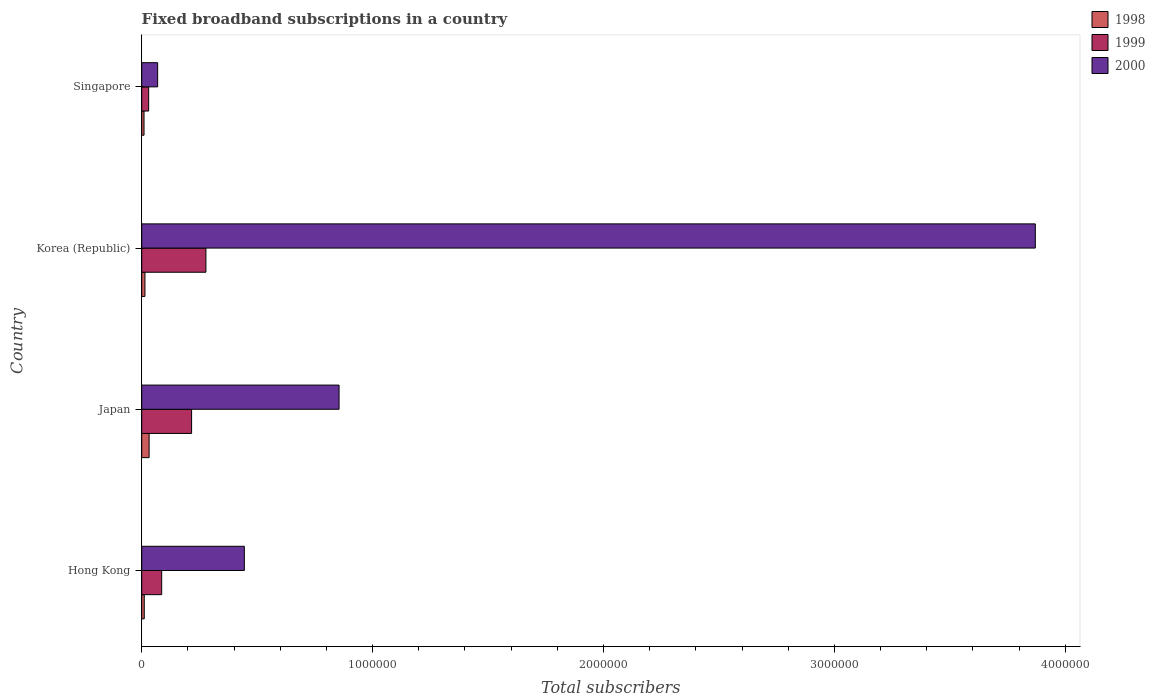How many groups of bars are there?
Keep it short and to the point. 4. Are the number of bars per tick equal to the number of legend labels?
Provide a short and direct response. Yes. Are the number of bars on each tick of the Y-axis equal?
Make the answer very short. Yes. How many bars are there on the 3rd tick from the top?
Provide a short and direct response. 3. What is the label of the 1st group of bars from the top?
Ensure brevity in your answer.  Singapore. Across all countries, what is the maximum number of broadband subscriptions in 1999?
Make the answer very short. 2.78e+05. Across all countries, what is the minimum number of broadband subscriptions in 1999?
Provide a short and direct response. 3.00e+04. In which country was the number of broadband subscriptions in 1999 minimum?
Make the answer very short. Singapore. What is the total number of broadband subscriptions in 1998 in the graph?
Provide a succinct answer. 6.70e+04. What is the difference between the number of broadband subscriptions in 1999 in Japan and that in Singapore?
Make the answer very short. 1.86e+05. What is the difference between the number of broadband subscriptions in 1999 in Singapore and the number of broadband subscriptions in 1998 in Korea (Republic)?
Make the answer very short. 1.60e+04. What is the average number of broadband subscriptions in 2000 per country?
Make the answer very short. 1.31e+06. What is the difference between the number of broadband subscriptions in 1998 and number of broadband subscriptions in 2000 in Japan?
Ensure brevity in your answer.  -8.23e+05. In how many countries, is the number of broadband subscriptions in 2000 greater than 600000 ?
Your answer should be very brief. 2. What is the ratio of the number of broadband subscriptions in 1999 in Korea (Republic) to that in Singapore?
Your answer should be very brief. 9.27. What is the difference between the highest and the second highest number of broadband subscriptions in 1999?
Ensure brevity in your answer.  6.20e+04. What is the difference between the highest and the lowest number of broadband subscriptions in 2000?
Your answer should be very brief. 3.80e+06. In how many countries, is the number of broadband subscriptions in 1999 greater than the average number of broadband subscriptions in 1999 taken over all countries?
Make the answer very short. 2. How many bars are there?
Provide a short and direct response. 12. Are all the bars in the graph horizontal?
Offer a very short reply. Yes. Are the values on the major ticks of X-axis written in scientific E-notation?
Your answer should be very brief. No. Does the graph contain any zero values?
Ensure brevity in your answer.  No. Does the graph contain grids?
Provide a short and direct response. No. How are the legend labels stacked?
Offer a very short reply. Vertical. What is the title of the graph?
Provide a short and direct response. Fixed broadband subscriptions in a country. Does "1979" appear as one of the legend labels in the graph?
Your answer should be compact. No. What is the label or title of the X-axis?
Give a very brief answer. Total subscribers. What is the label or title of the Y-axis?
Offer a terse response. Country. What is the Total subscribers of 1998 in Hong Kong?
Keep it short and to the point. 1.10e+04. What is the Total subscribers in 1999 in Hong Kong?
Your answer should be very brief. 8.65e+04. What is the Total subscribers in 2000 in Hong Kong?
Make the answer very short. 4.44e+05. What is the Total subscribers in 1998 in Japan?
Your answer should be very brief. 3.20e+04. What is the Total subscribers in 1999 in Japan?
Ensure brevity in your answer.  2.16e+05. What is the Total subscribers in 2000 in Japan?
Ensure brevity in your answer.  8.55e+05. What is the Total subscribers in 1998 in Korea (Republic)?
Your answer should be very brief. 1.40e+04. What is the Total subscribers in 1999 in Korea (Republic)?
Give a very brief answer. 2.78e+05. What is the Total subscribers in 2000 in Korea (Republic)?
Your response must be concise. 3.87e+06. What is the Total subscribers of 1998 in Singapore?
Provide a succinct answer. 10000. What is the Total subscribers in 1999 in Singapore?
Your answer should be very brief. 3.00e+04. What is the Total subscribers of 2000 in Singapore?
Keep it short and to the point. 6.90e+04. Across all countries, what is the maximum Total subscribers in 1998?
Make the answer very short. 3.20e+04. Across all countries, what is the maximum Total subscribers of 1999?
Your answer should be compact. 2.78e+05. Across all countries, what is the maximum Total subscribers of 2000?
Your answer should be compact. 3.87e+06. Across all countries, what is the minimum Total subscribers in 2000?
Provide a succinct answer. 6.90e+04. What is the total Total subscribers of 1998 in the graph?
Keep it short and to the point. 6.70e+04. What is the total Total subscribers of 1999 in the graph?
Make the answer very short. 6.10e+05. What is the total Total subscribers in 2000 in the graph?
Your response must be concise. 5.24e+06. What is the difference between the Total subscribers of 1998 in Hong Kong and that in Japan?
Offer a very short reply. -2.10e+04. What is the difference between the Total subscribers of 1999 in Hong Kong and that in Japan?
Your answer should be compact. -1.30e+05. What is the difference between the Total subscribers of 2000 in Hong Kong and that in Japan?
Your response must be concise. -4.10e+05. What is the difference between the Total subscribers of 1998 in Hong Kong and that in Korea (Republic)?
Provide a succinct answer. -3000. What is the difference between the Total subscribers in 1999 in Hong Kong and that in Korea (Republic)?
Provide a succinct answer. -1.92e+05. What is the difference between the Total subscribers in 2000 in Hong Kong and that in Korea (Republic)?
Offer a terse response. -3.43e+06. What is the difference between the Total subscribers of 1999 in Hong Kong and that in Singapore?
Offer a terse response. 5.65e+04. What is the difference between the Total subscribers of 2000 in Hong Kong and that in Singapore?
Your response must be concise. 3.75e+05. What is the difference between the Total subscribers in 1998 in Japan and that in Korea (Republic)?
Keep it short and to the point. 1.80e+04. What is the difference between the Total subscribers in 1999 in Japan and that in Korea (Republic)?
Keep it short and to the point. -6.20e+04. What is the difference between the Total subscribers of 2000 in Japan and that in Korea (Republic)?
Provide a short and direct response. -3.02e+06. What is the difference between the Total subscribers in 1998 in Japan and that in Singapore?
Your answer should be very brief. 2.20e+04. What is the difference between the Total subscribers in 1999 in Japan and that in Singapore?
Your answer should be very brief. 1.86e+05. What is the difference between the Total subscribers of 2000 in Japan and that in Singapore?
Your response must be concise. 7.86e+05. What is the difference between the Total subscribers in 1998 in Korea (Republic) and that in Singapore?
Offer a terse response. 4000. What is the difference between the Total subscribers of 1999 in Korea (Republic) and that in Singapore?
Provide a succinct answer. 2.48e+05. What is the difference between the Total subscribers in 2000 in Korea (Republic) and that in Singapore?
Provide a succinct answer. 3.80e+06. What is the difference between the Total subscribers in 1998 in Hong Kong and the Total subscribers in 1999 in Japan?
Ensure brevity in your answer.  -2.05e+05. What is the difference between the Total subscribers in 1998 in Hong Kong and the Total subscribers in 2000 in Japan?
Your response must be concise. -8.44e+05. What is the difference between the Total subscribers of 1999 in Hong Kong and the Total subscribers of 2000 in Japan?
Your answer should be compact. -7.68e+05. What is the difference between the Total subscribers in 1998 in Hong Kong and the Total subscribers in 1999 in Korea (Republic)?
Provide a short and direct response. -2.67e+05. What is the difference between the Total subscribers of 1998 in Hong Kong and the Total subscribers of 2000 in Korea (Republic)?
Your answer should be very brief. -3.86e+06. What is the difference between the Total subscribers of 1999 in Hong Kong and the Total subscribers of 2000 in Korea (Republic)?
Your response must be concise. -3.78e+06. What is the difference between the Total subscribers in 1998 in Hong Kong and the Total subscribers in 1999 in Singapore?
Your response must be concise. -1.90e+04. What is the difference between the Total subscribers in 1998 in Hong Kong and the Total subscribers in 2000 in Singapore?
Provide a succinct answer. -5.80e+04. What is the difference between the Total subscribers of 1999 in Hong Kong and the Total subscribers of 2000 in Singapore?
Give a very brief answer. 1.75e+04. What is the difference between the Total subscribers in 1998 in Japan and the Total subscribers in 1999 in Korea (Republic)?
Ensure brevity in your answer.  -2.46e+05. What is the difference between the Total subscribers in 1998 in Japan and the Total subscribers in 2000 in Korea (Republic)?
Offer a very short reply. -3.84e+06. What is the difference between the Total subscribers in 1999 in Japan and the Total subscribers in 2000 in Korea (Republic)?
Provide a short and direct response. -3.65e+06. What is the difference between the Total subscribers of 1998 in Japan and the Total subscribers of 2000 in Singapore?
Your answer should be compact. -3.70e+04. What is the difference between the Total subscribers of 1999 in Japan and the Total subscribers of 2000 in Singapore?
Provide a succinct answer. 1.47e+05. What is the difference between the Total subscribers of 1998 in Korea (Republic) and the Total subscribers of 1999 in Singapore?
Offer a terse response. -1.60e+04. What is the difference between the Total subscribers in 1998 in Korea (Republic) and the Total subscribers in 2000 in Singapore?
Your response must be concise. -5.50e+04. What is the difference between the Total subscribers in 1999 in Korea (Republic) and the Total subscribers in 2000 in Singapore?
Provide a succinct answer. 2.09e+05. What is the average Total subscribers in 1998 per country?
Offer a terse response. 1.68e+04. What is the average Total subscribers in 1999 per country?
Offer a very short reply. 1.53e+05. What is the average Total subscribers of 2000 per country?
Offer a terse response. 1.31e+06. What is the difference between the Total subscribers in 1998 and Total subscribers in 1999 in Hong Kong?
Ensure brevity in your answer.  -7.55e+04. What is the difference between the Total subscribers in 1998 and Total subscribers in 2000 in Hong Kong?
Offer a very short reply. -4.33e+05. What is the difference between the Total subscribers in 1999 and Total subscribers in 2000 in Hong Kong?
Provide a succinct answer. -3.58e+05. What is the difference between the Total subscribers of 1998 and Total subscribers of 1999 in Japan?
Your answer should be compact. -1.84e+05. What is the difference between the Total subscribers in 1998 and Total subscribers in 2000 in Japan?
Provide a succinct answer. -8.23e+05. What is the difference between the Total subscribers of 1999 and Total subscribers of 2000 in Japan?
Your response must be concise. -6.39e+05. What is the difference between the Total subscribers in 1998 and Total subscribers in 1999 in Korea (Republic)?
Your response must be concise. -2.64e+05. What is the difference between the Total subscribers in 1998 and Total subscribers in 2000 in Korea (Republic)?
Your response must be concise. -3.86e+06. What is the difference between the Total subscribers of 1999 and Total subscribers of 2000 in Korea (Republic)?
Offer a terse response. -3.59e+06. What is the difference between the Total subscribers of 1998 and Total subscribers of 1999 in Singapore?
Provide a succinct answer. -2.00e+04. What is the difference between the Total subscribers in 1998 and Total subscribers in 2000 in Singapore?
Provide a short and direct response. -5.90e+04. What is the difference between the Total subscribers of 1999 and Total subscribers of 2000 in Singapore?
Provide a succinct answer. -3.90e+04. What is the ratio of the Total subscribers of 1998 in Hong Kong to that in Japan?
Your answer should be compact. 0.34. What is the ratio of the Total subscribers of 1999 in Hong Kong to that in Japan?
Offer a terse response. 0.4. What is the ratio of the Total subscribers in 2000 in Hong Kong to that in Japan?
Give a very brief answer. 0.52. What is the ratio of the Total subscribers of 1998 in Hong Kong to that in Korea (Republic)?
Your response must be concise. 0.79. What is the ratio of the Total subscribers in 1999 in Hong Kong to that in Korea (Republic)?
Your answer should be very brief. 0.31. What is the ratio of the Total subscribers in 2000 in Hong Kong to that in Korea (Republic)?
Your response must be concise. 0.11. What is the ratio of the Total subscribers in 1999 in Hong Kong to that in Singapore?
Offer a very short reply. 2.88. What is the ratio of the Total subscribers in 2000 in Hong Kong to that in Singapore?
Provide a short and direct response. 6.44. What is the ratio of the Total subscribers of 1998 in Japan to that in Korea (Republic)?
Give a very brief answer. 2.29. What is the ratio of the Total subscribers in 1999 in Japan to that in Korea (Republic)?
Offer a very short reply. 0.78. What is the ratio of the Total subscribers of 2000 in Japan to that in Korea (Republic)?
Your answer should be very brief. 0.22. What is the ratio of the Total subscribers in 1998 in Japan to that in Singapore?
Offer a very short reply. 3.2. What is the ratio of the Total subscribers in 2000 in Japan to that in Singapore?
Offer a very short reply. 12.39. What is the ratio of the Total subscribers in 1998 in Korea (Republic) to that in Singapore?
Make the answer very short. 1.4. What is the ratio of the Total subscribers in 1999 in Korea (Republic) to that in Singapore?
Your answer should be compact. 9.27. What is the ratio of the Total subscribers in 2000 in Korea (Republic) to that in Singapore?
Make the answer very short. 56.09. What is the difference between the highest and the second highest Total subscribers in 1998?
Give a very brief answer. 1.80e+04. What is the difference between the highest and the second highest Total subscribers of 1999?
Provide a succinct answer. 6.20e+04. What is the difference between the highest and the second highest Total subscribers in 2000?
Provide a short and direct response. 3.02e+06. What is the difference between the highest and the lowest Total subscribers of 1998?
Offer a very short reply. 2.20e+04. What is the difference between the highest and the lowest Total subscribers of 1999?
Provide a short and direct response. 2.48e+05. What is the difference between the highest and the lowest Total subscribers in 2000?
Ensure brevity in your answer.  3.80e+06. 